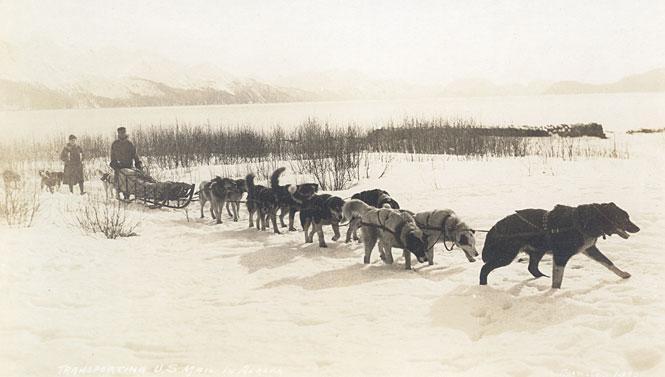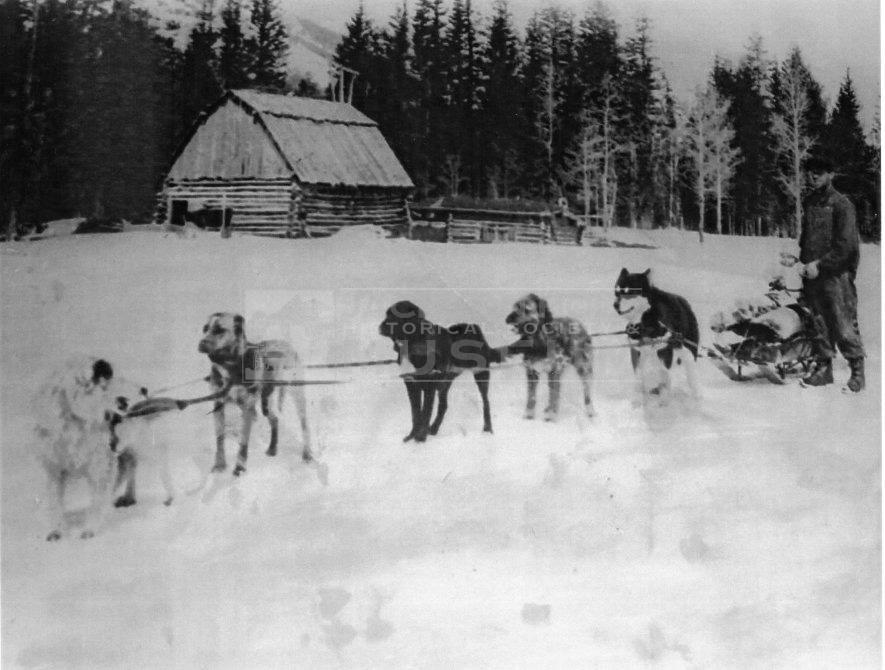The first image is the image on the left, the second image is the image on the right. Given the left and right images, does the statement "Each image shows a dog team with a standing sled driver at the back in a snow-covered field with no business buildings in view." hold true? Answer yes or no. Yes. The first image is the image on the left, the second image is the image on the right. Examine the images to the left and right. Is the description "There are fewer than four people in total." accurate? Answer yes or no. Yes. 